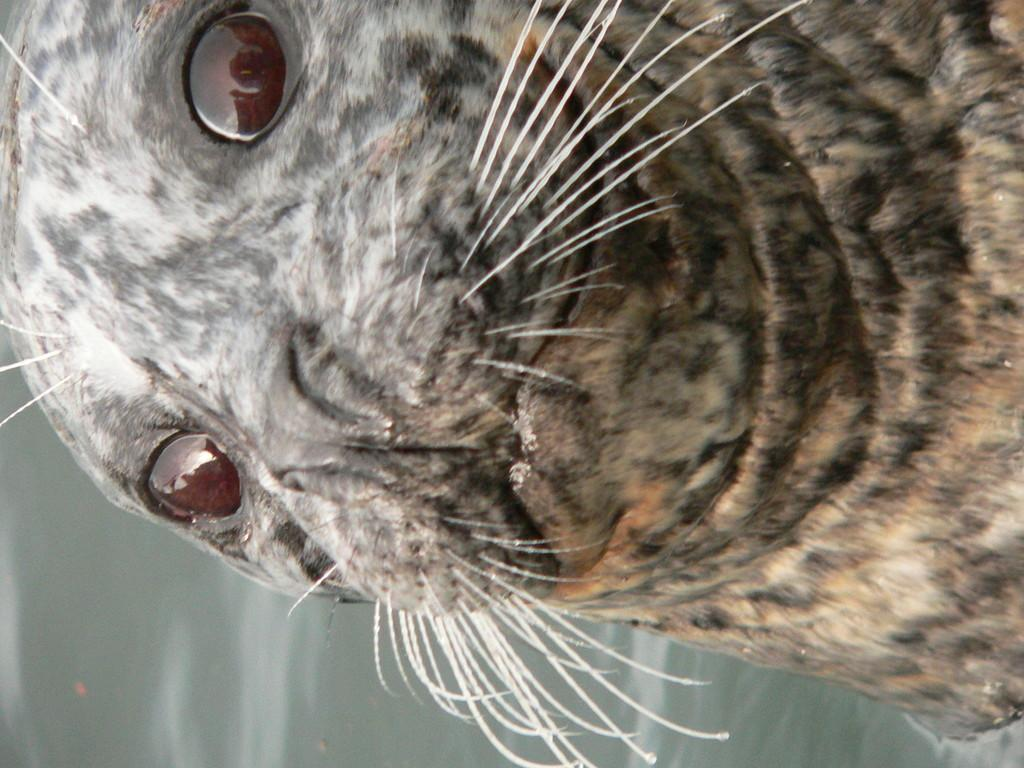What animal is present in the image? There is a seal in the image. Where is the seal located? The seal is in the water. What type of skirt is the seal wearing in the image? There is no skirt present in the image, as seals do not wear clothing. 